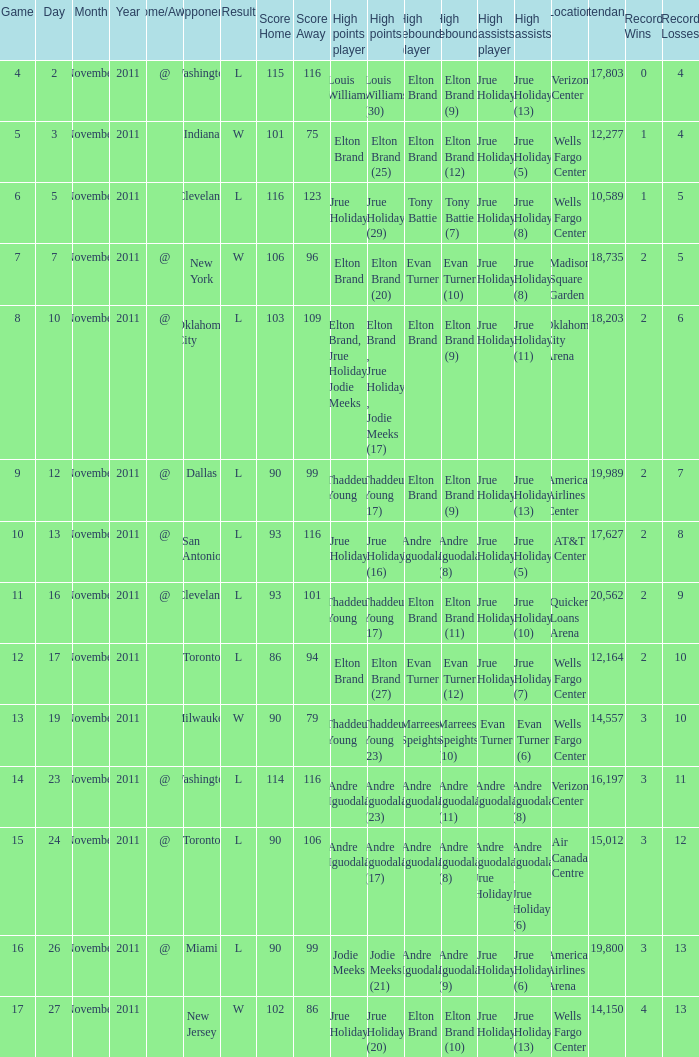How many games are shown for the game where andre iguodala (9) had the high rebounds? 1.0. 